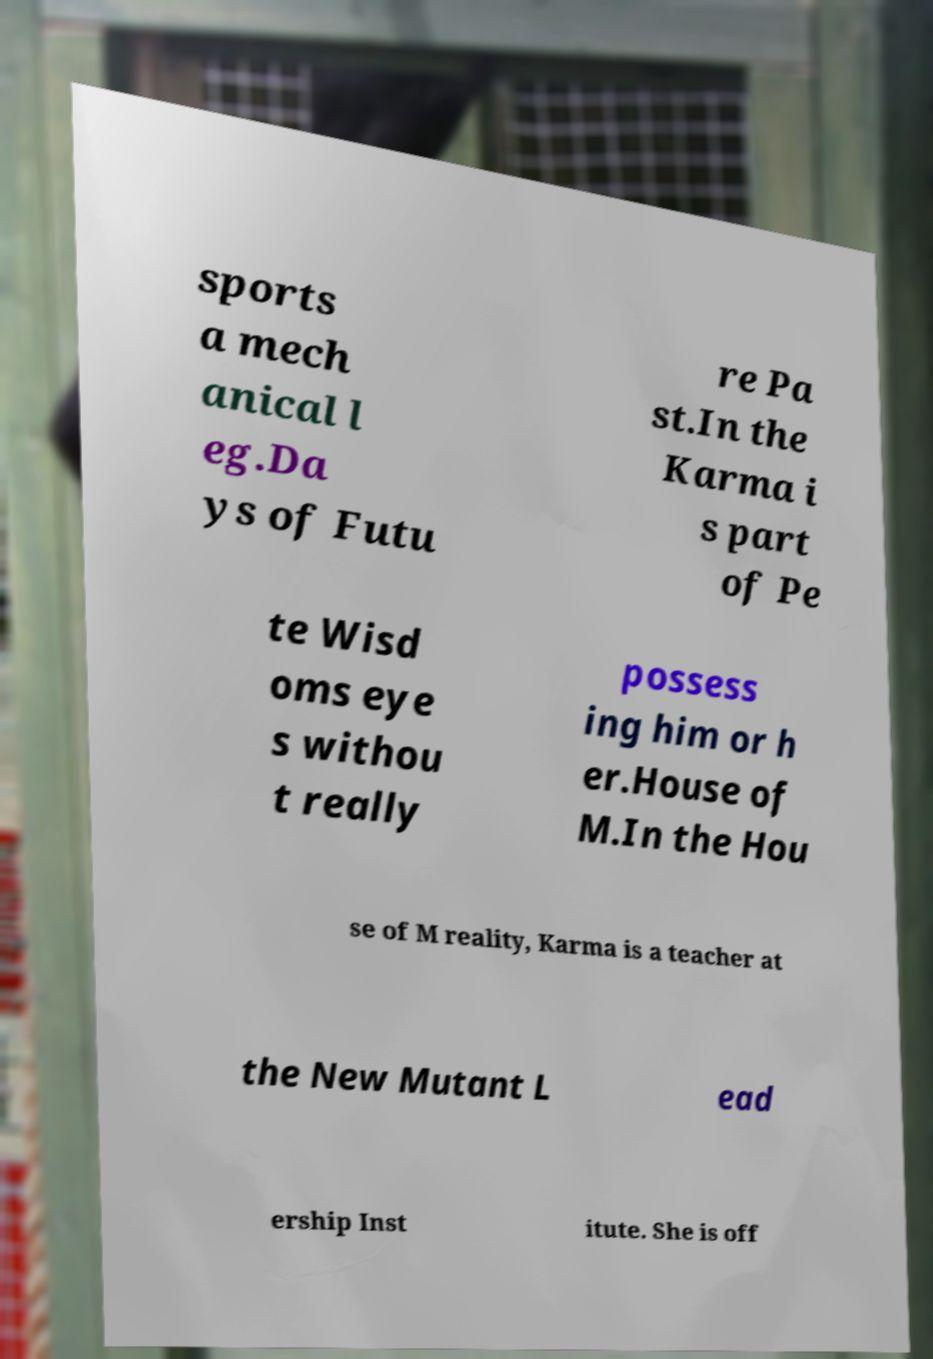Could you assist in decoding the text presented in this image and type it out clearly? sports a mech anical l eg.Da ys of Futu re Pa st.In the Karma i s part of Pe te Wisd oms eye s withou t really possess ing him or h er.House of M.In the Hou se of M reality, Karma is a teacher at the New Mutant L ead ership Inst itute. She is off 